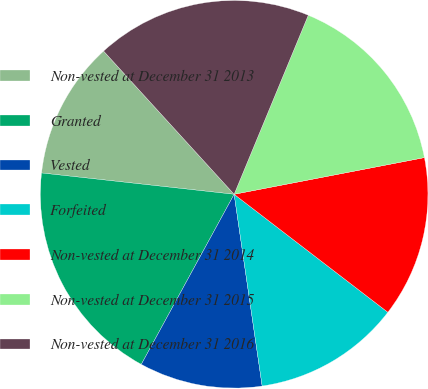Convert chart to OTSL. <chart><loc_0><loc_0><loc_500><loc_500><pie_chart><fcel>Non-vested at December 31 2013<fcel>Granted<fcel>Vested<fcel>Forfeited<fcel>Non-vested at December 31 2014<fcel>Non-vested at December 31 2015<fcel>Non-vested at December 31 2016<nl><fcel>11.48%<fcel>18.8%<fcel>10.26%<fcel>12.27%<fcel>13.45%<fcel>15.72%<fcel>18.01%<nl></chart> 